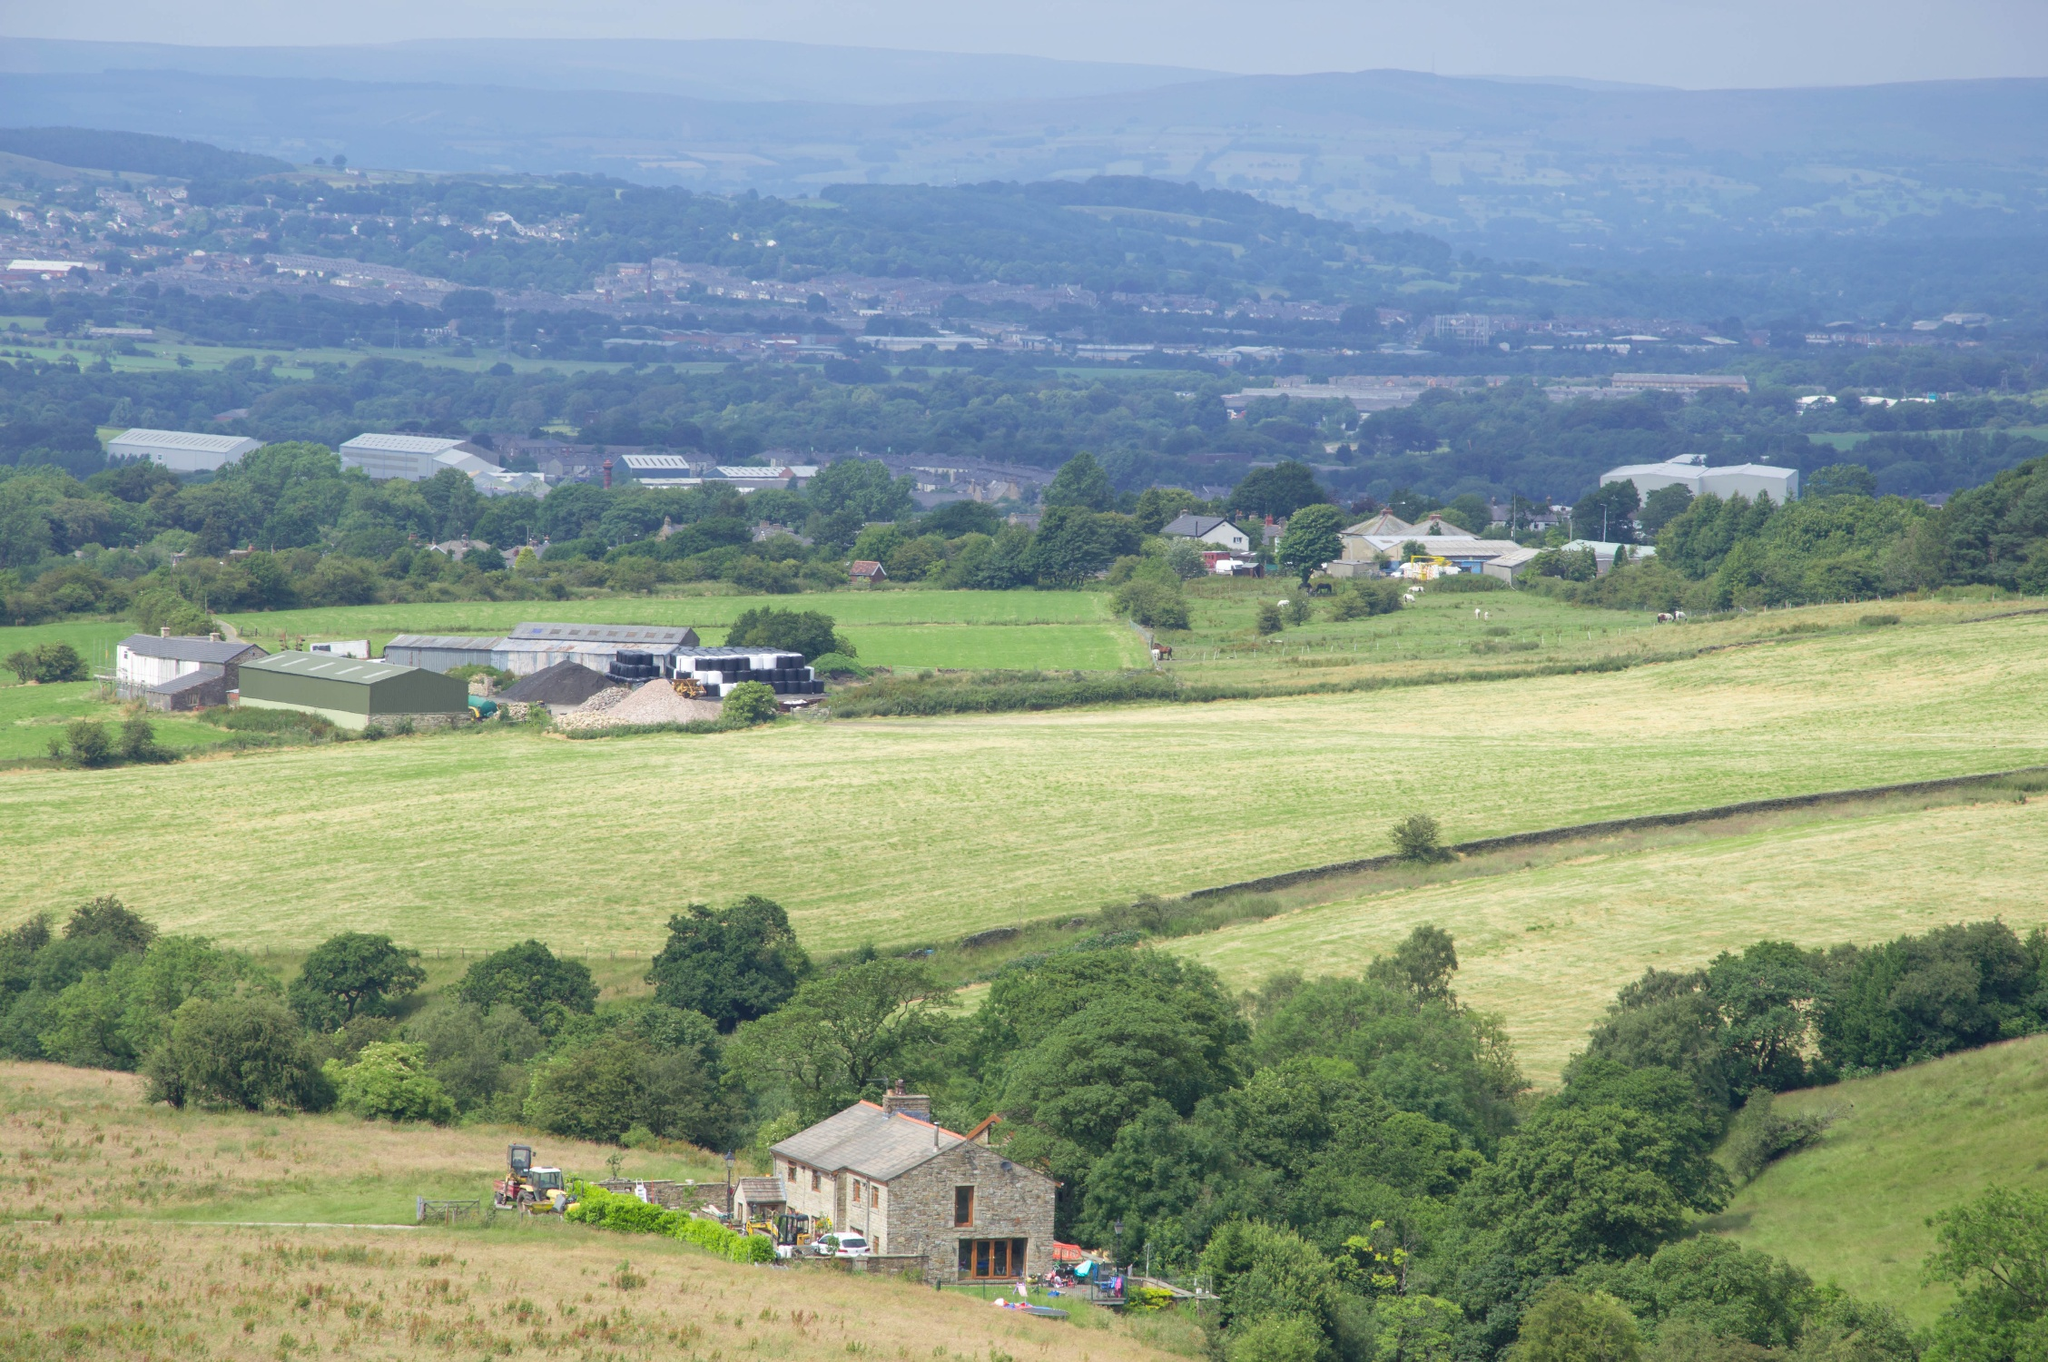Imagine an ancient civilization lived here. What remnants or artifacts might they have left behind? If an ancient civilization once thrived in this landscape, you might find an array of fascinating remnants and artifacts. Stone tools, pottery shards, and remnants of ancient dwellings made from local stone and wood could be scattered across the fields. You might also discover burial mounds or cairns on the hills, marking significant spiritual or cultural sites. In areas where ancient agriculture took place, remnants of terracing or irrigation systems could be found. Additionally, the tree lines might have been used to delineate property boundaries or sacred groves, with some trees potentially serving as ancient markers or gathering spots. Overall, these artifacts would provide valuable insights into the daily lives, spiritual practices, and agricultural methods of the people who once inhabited this land. What kind of community events or festivals might the local residents organize annually? The local residents might organize a variety of community events and festivals that celebrate their agricultural heritage and natural surroundings. An annual harvest festival could be a highlight, featuring activities like crop displays, farming competitions, local food and craft markets, and traditional music and dance. During spring, a blossom festival might mark the beginning of the growing season, with guided walks through blooming fields and tree lines, emphasizing nature appreciation. Summer could host outdoor theater performances or picnics on the hills, offering stunning views of the landscape. In the winter, a festival centered around local folklore, storytelling, and bonfires could bring the community together to celebrate the end of the agricultural cycle and prepare for the new year.  If this landscape were part of a fantasy world, what mystical creatures and legends might inhabit it? In a fantasy world, this landscape could be teeming with mystical creatures and legends. Imagine gentle forest spirits known as Dryads inhabiting the tree lines, protecting the lands and maintaining harmony with nature. The hills could be home to wise, old creatures like Griffins or ancient dragons that protect hidden treasures buried deep within. Fields might host elusive Fairy folk, who bring prosperity to crops and mischievously play with humans. Legends could tell of an enchanted farmhouse where a benevolent mage once lived, leaving behind powerful artifacts and spells that shield the community. At night, will-o’-the-wisps could dance through the valleys, guiding lost travelers to safety or leading them deeper into enchanted woods. These myths and creatures would imbue the landscape with a sense of mystery and wonder, enriching its cultural tapestry.  Describe a long-term realistic scenario where this landscape evolves into an ecological reserve. Imagine a long-term scenario where this beautiful landscape is transformed into an ecological reserve. Over several decades, dedicated conservation efforts have led to the restoration of natural habitats and the reintroduction of native species. The open fields become meadows filled with wildflowers and grasses, attracting pollinators like bees and butterflies. The hills are reforested with native trees, enhancing biodiversity by providing habitats for birds, small mammals, and insects. Wetlands are created in low-lying areas, supporting aquatic plants and encouraging the return of amphibians and waterfowl. Educational trails are established, with information boards that explain the significance of different parts of the reserve and the species that thrive there. The former farmhouse is converted into a visitor center, offering guided tours, interactive exhibits, and research facilities for scientists studying the ecosystem. Local schools participate in hands-on learning programs, fostering a deeper connection between the community and their natural surroundings. Over time, the ecological reserve becomes a cherished sanctuary, demonstrating the positive impact of conservation and the importance of protecting natural landscapes for future generations.  What might a typical day be like for a farmer working in this area? A typical day for a farmer working in this area would likely start early in the morning. As dawn breaks, the farmer would head out to tend to the crops or livestock, taking advantage of the cooler temperatures. The day's tasks could vary, from planting or harvesting crops in the fields to caring for animals in the barns and pastures. Mid-morning might involve checking the condition of fences, irrigation systems, and machinery, ensuring everything is in working order. After a hearty lunch, the farmer might spend the afternoon in the fields again, perhaps weeding, fertilizing, or managing pest control. If the weather is favorable, more time might be spent outdoors, whereas rainy or colder days could involve indoor tasks such as maintaining equipment or planning for future planting seasons. By late afternoon, the farmer might gather produce for local markets or prepare feed for the animals. As the sun sets, there would be a final check on the livestock and a walk around the property to ensure everything is secure for the night. Evenings would be spent updating records, planning the next day's activities, and enjoying a well-earned rest with family. 